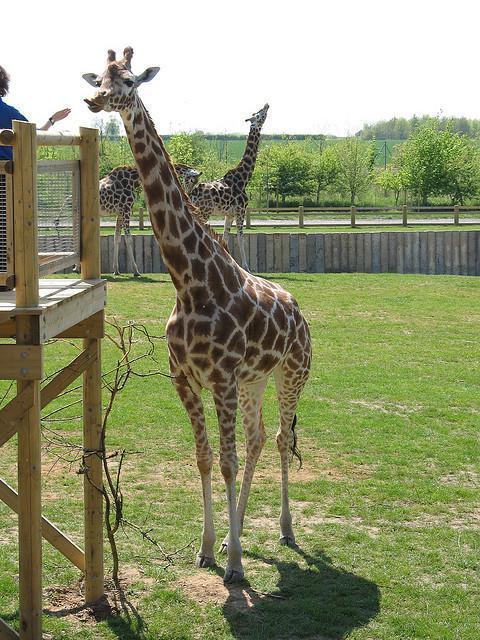How many giraffes are in the picture?
Give a very brief answer. 3. How many giraffes can be seen?
Give a very brief answer. 3. How many orange cars are there in the picture?
Give a very brief answer. 0. 